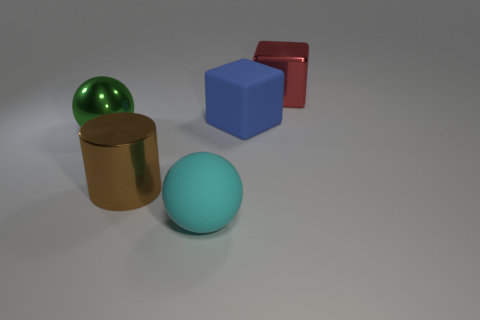Can you describe the shapes and their colors in this image? Certainly, the image showcases a variety of geometric shapes with different colors and materials. There's a large green-colored sphere with a reflective surface, similar to the smaller red cube on the right. In addition, there's a smaller aqua-colored sphere in front and a gold cylindrical object on the left, which all rest on a neutral grey surface.  What could be the purpose of arranging these objects like this? This arrangement appears to be a deliberate composition possibly for a study of geometry, lighting, and reflection. The objects could be used for educational purposes, to demonstrate 3D modeling, or as an artistic display that emphasizes forms and colors with their interactions with light. 